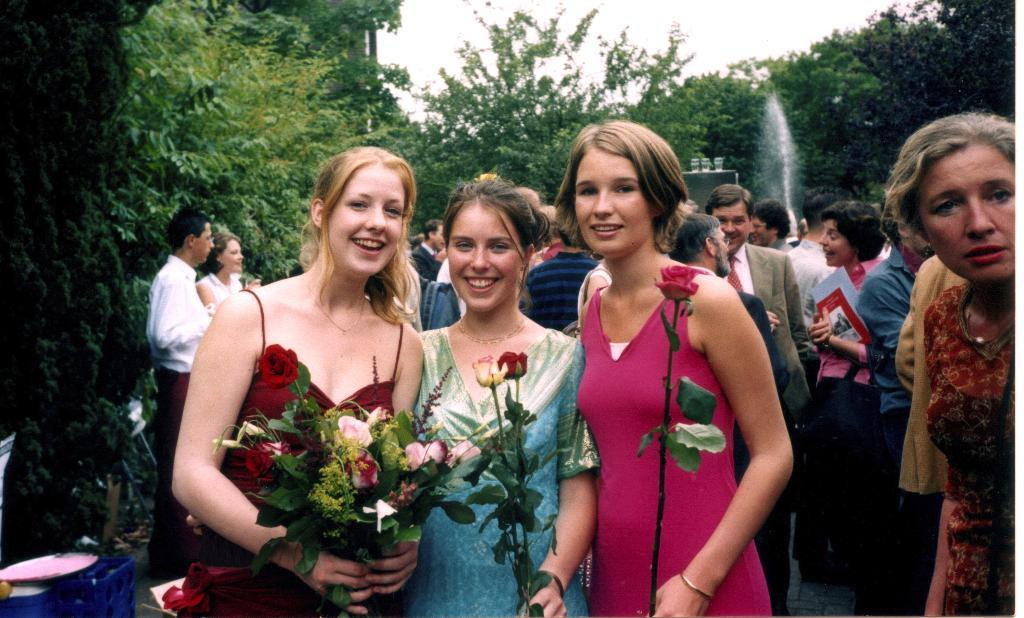What is the girl in the image doing? The beautiful girl in the image is standing and smiling. What is the girl holding in her hands? The girl is holding rose flowers in her hands. Are there any other people in the image? Yes, there are two other girls standing behind the beautiful girl. What can be seen in the background of the image? There are trees visible in the image. What type of crown is the girl wearing in the image? There is no crown visible on the girl in the image. What kind of copper vessel can be seen near the trees in the image? There is no copper vessel present in the image; only trees are visible in the background. 